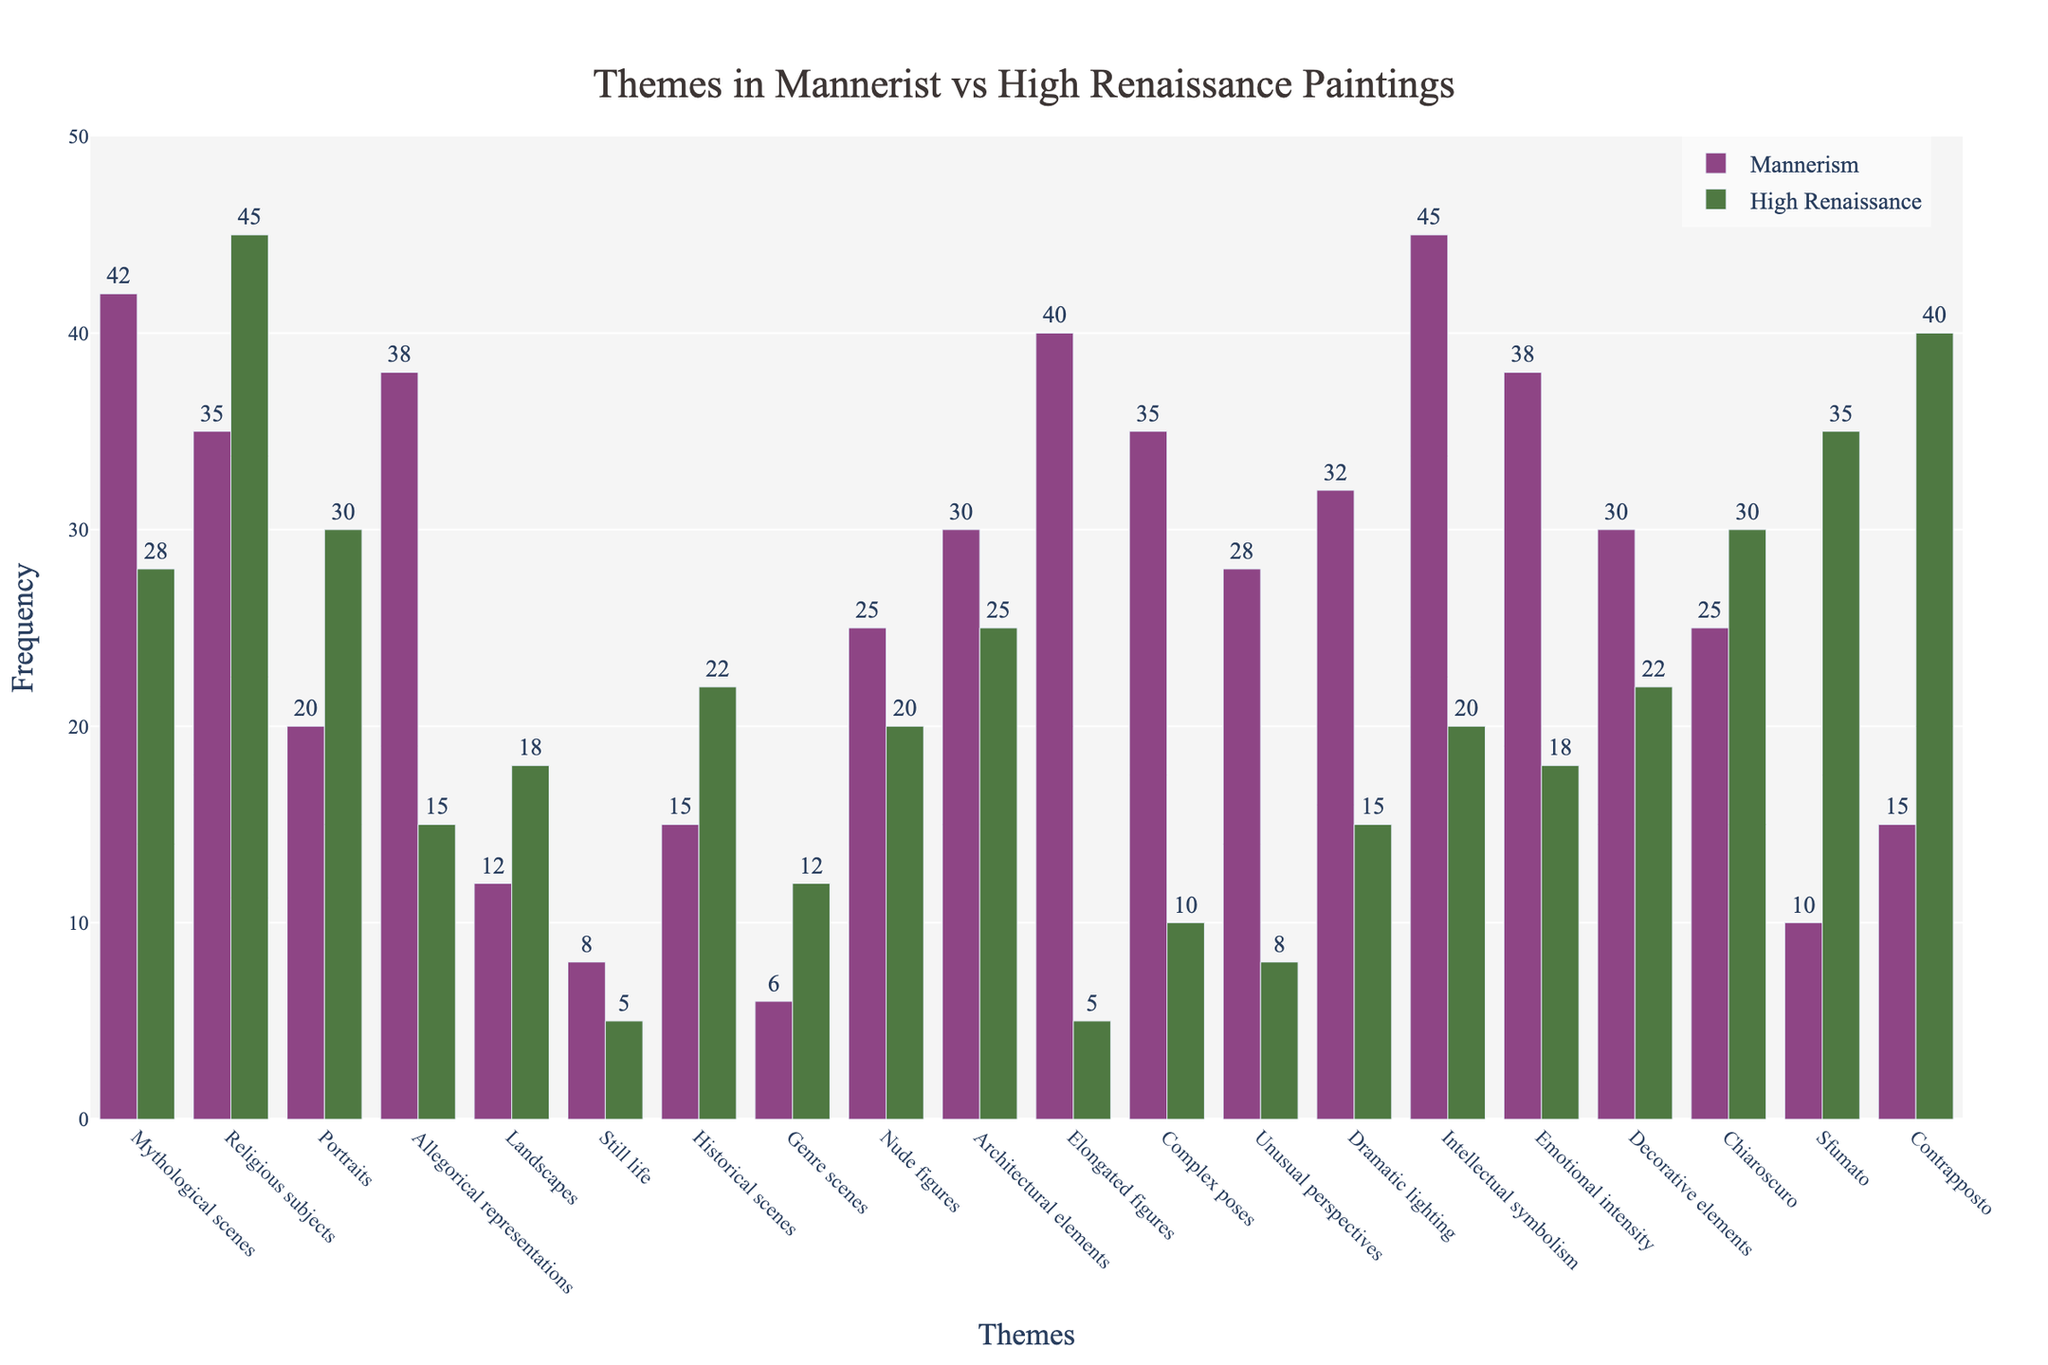What is the frequency of mythological scenes in Mannerist paintings? The frequency of mythological scenes in Mannerist paintings can be directly read from the bar labeled "Mythological scenes" under the "Mannerism" category.
Answer: 42 Which theme shows the greatest frequency difference between Mannerism and High Renaissance? To determine the greatest frequency difference, calculate the absolute difference for each theme between the two categories and find the largest value. The differences are: Mythological scenes (14), Religious subjects (10), Portraits (10), Allegorical representations (23), Landscapes (6), Still life (3), Historical scenes (7), Genre scenes (6), Nude figures (5), Architectural elements (5), Elongated figures (35), Complex poses (25), Unusual perspectives (20), Dramatic lighting (17), Intellectual symbolism (25), Emotional intensity (20), Decorative elements (8), Chiaroscuro (5), Sfumato (25), Contrapposto (25). Elongated figures show the greatest difference at 35.
Answer: Elongated figures What is the total frequency of Religious subjects and Portraits in High Renaissance paintings? Sum the frequencies of Religious subjects and Portraits in High Renaissance from the respective bars. Religious subjects have a frequency of 45 and Portraits have a frequency of 30. Adding these gives 45 + 30 = 75.
Answer: 75 Which themes have higher frequencies in High Renaissance paintings than in Mannerist paintings? Compare the individual bar heights of each theme in High Renaissance with those in Mannerism. The themes with higher frequencies in High Renaissance compared to Mannerism are: Religious subjects, Portraits, Landscapes, Historical scenes, Genre scenes, Chiaroscuro, Sfumato, and Contrapposto.
Answer: 8 themes What is the difference in frequencies of Mythological scenes and Allegorical representations in Mannerist paintings? Read the values from Mannerist paintings for both themes and subtract the smaller number from the larger. Mythological scenes have a frequency of 42 and Allegorical representations have 38. Therefore, the difference is 42 - 38 = 4.
Answer: 4 